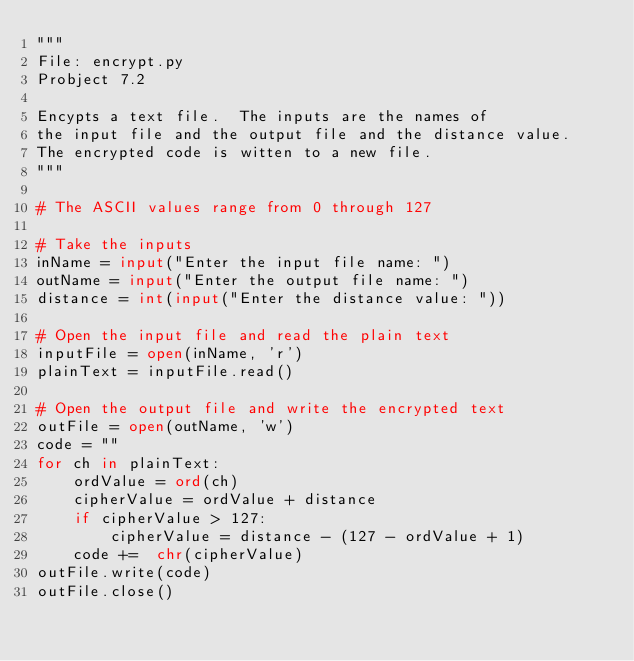Convert code to text. <code><loc_0><loc_0><loc_500><loc_500><_Python_>"""
File: encrypt.py
Probject 7.2

Encypts a text file.  The inputs are the names of
the input file and the output file and the distance value.
The encrypted code is witten to a new file.
"""

# The ASCII values range from 0 through 127

# Take the inputs
inName = input("Enter the input file name: ")
outName = input("Enter the output file name: ")
distance = int(input("Enter the distance value: "))

# Open the input file and read the plain text
inputFile = open(inName, 'r')
plainText = inputFile.read()

# Open the output file and write the encrypted text
outFile = open(outName, 'w')
code = ""
for ch in plainText:
    ordValue = ord(ch)
    cipherValue = ordValue + distance
    if cipherValue > 127:
        cipherValue = distance - (127 - ordValue + 1)
    code +=  chr(cipherValue)
outFile.write(code)
outFile.close()
</code> 